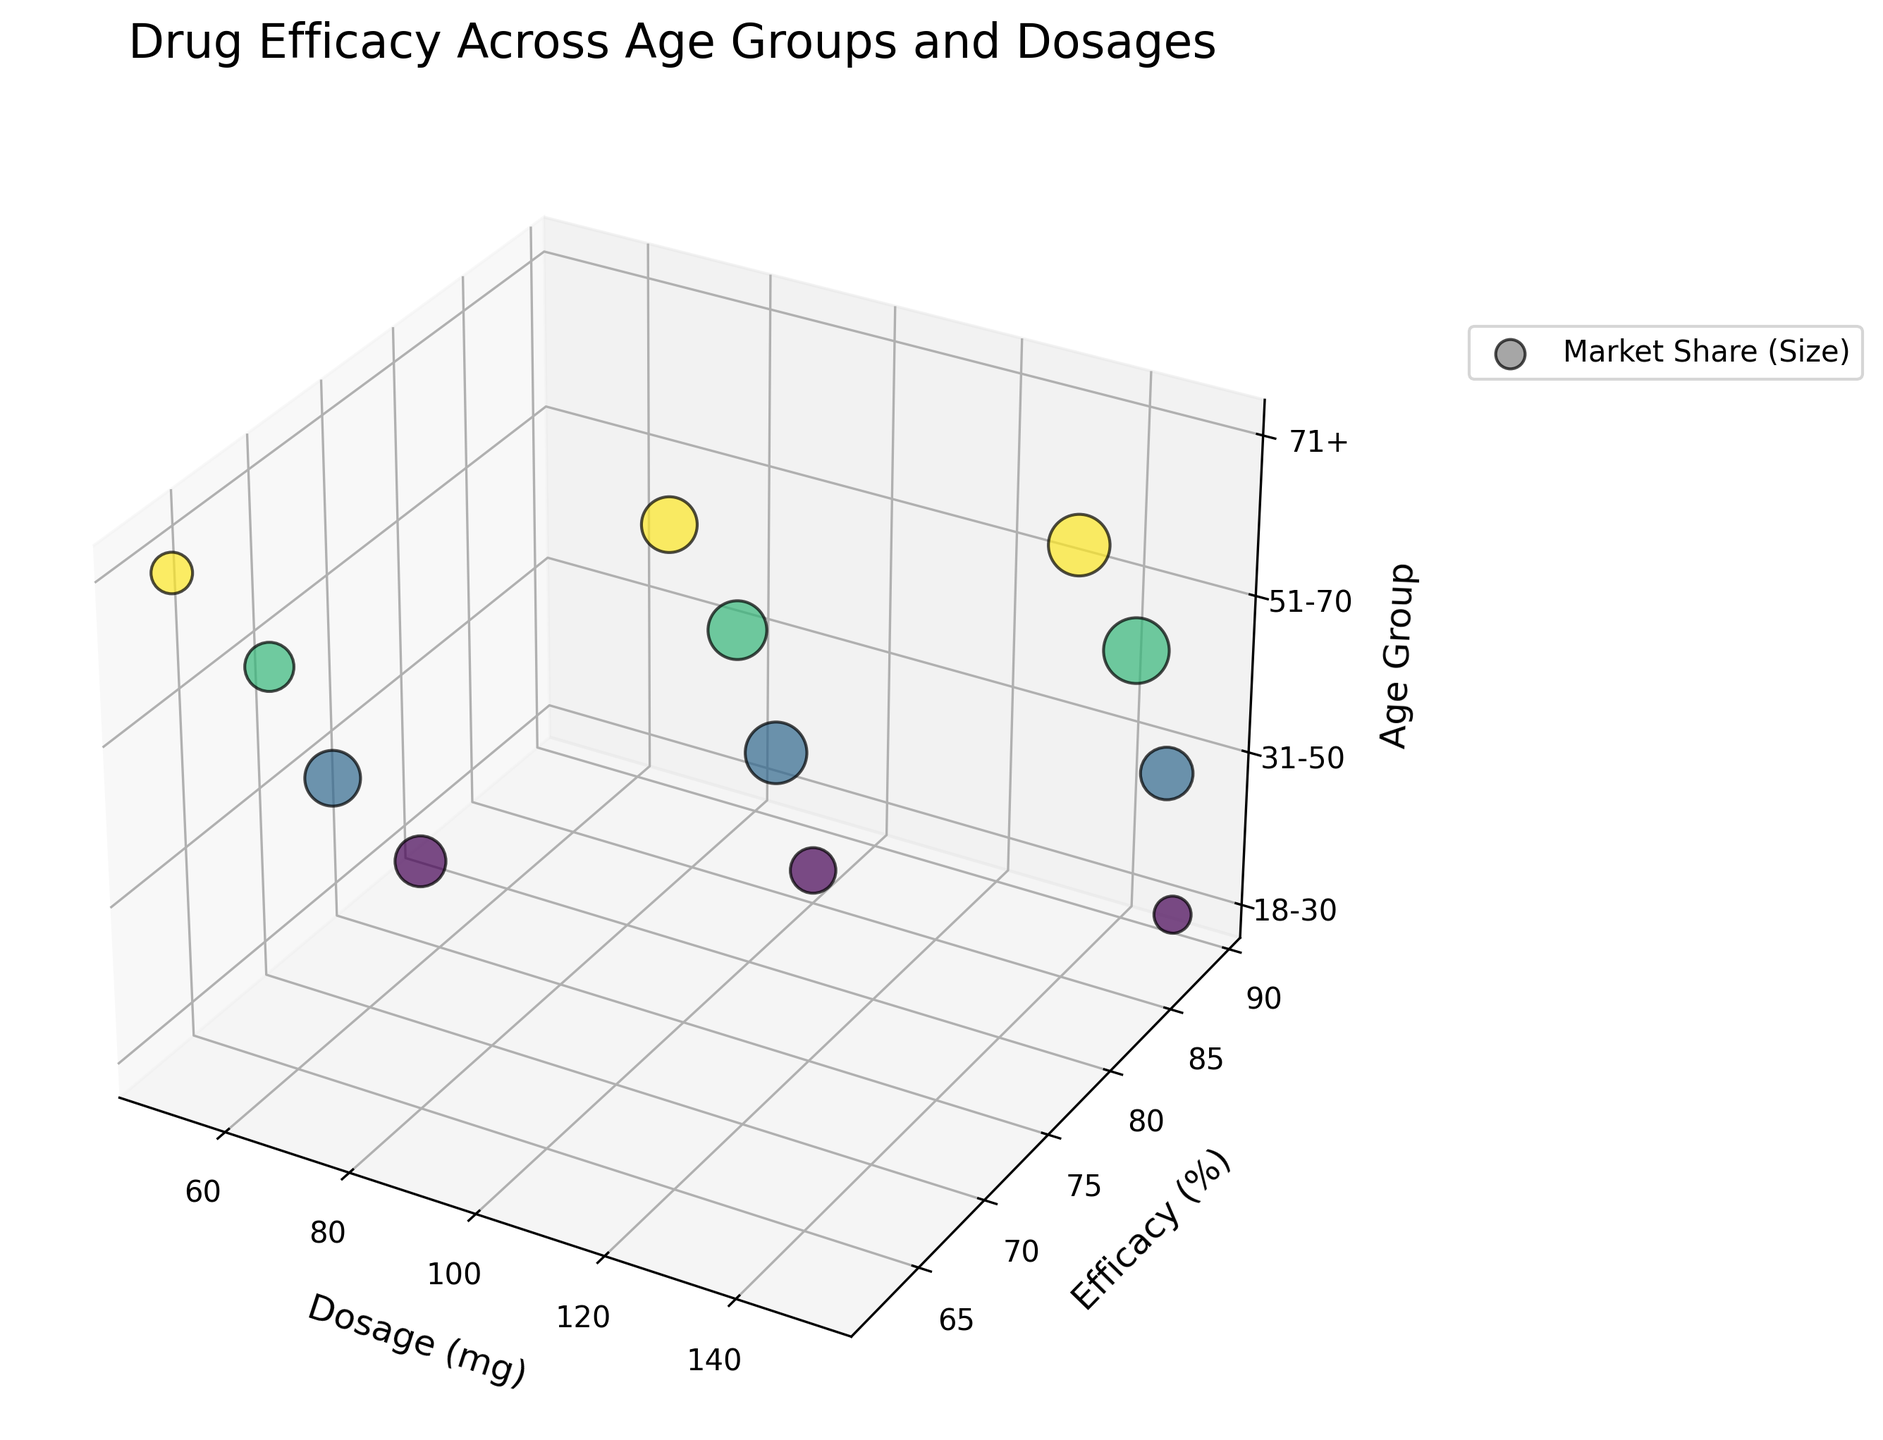what is the title of the figure? The title of the figure is typically displayed at the top of the plot. It summarizes what the graph is about. In this case, the title is directly visible.
Answer: Drug Efficacy Across Age Groups and Dosages What is the age group with the highest efficacy at 100 mg dosage? The age group with the highest efficacy at 100 mg is found by locating the data point along the Dosage (mg) axis (100mg) and checking which age group has the highest Efficacy (%) value for that dosage.
Answer: 18-30 Which dosage level has the highest market share in the 51-70 age group? To find this, we need to look at the data points for the 51-70 age group and compare the sizes of the bubbles at various dosage levels (50 mg, 100 mg, 150 mg). The bubble with the largest size corresponds to the highest market share.
Answer: 150 mg How does the efficacy change with increasing dosage in the 31-50 age group? By examining the data points for the 31-50 age group, we can observe how the Efficacy (%) values change as we move from 50 mg to 150 mg dosage. This involves observing the trend in the efficacy percentages.
Answer: Increases Compare the market share for the 71+ age group to all other age groups at 50 mg dosage. This involves examining and comparing the sizes of the bubbles at the 50 mg dosage level for the 71+ age group and the other age groups (18-30, 31-50, 51-70). Larger bubbles indicate higher market shares.
Answer: Lower than all other age groups Which age group shows the most significant increase in efficacy from 50 mg to 150 mg dosage? Compare the efficacy percentages for each age group at 50 mg and 150 mg dosages. Calculate the increase for each group and identify which one has the largest difference.
Answer: 18-30 What age group and dosage corresponds to the smallest bubble size representing market share? Identify the smallest bubble in the figure, then note its corresponding age group and dosage level by tracing back to the axes.
Answer: 18-30, 150 mg Which age group has the least variation in efficacy across different dosages? To find this, look at the efficacy percentages for each age group across different dosages (50 mg, 100 mg, 150 mg). Calculate the range (maximum - minimum) of efficacy values for each age group and compare them to see which has the smallest range.
Answer: 31-50 How does the market share for the 18-30 age group at 100 mg compare to the 71+ age group at 150 mg? Look at the sizes of the bubbles representing the market share for the 18-30 age group at 100 mg dosage and the 71+ age group at 150 mg dosage. The size of the bubble indicates the market share percentage.
Answer: Smaller What is the efficacy trend for 71+ age group with increasing dosage? Examine the data points for the 71+ age group and observe the change in efficacy percentages as the dosage increases from 50 mg to 150 mg. This will show if there's an increasing, decreasing, or constant trend.
Answer: Increases 